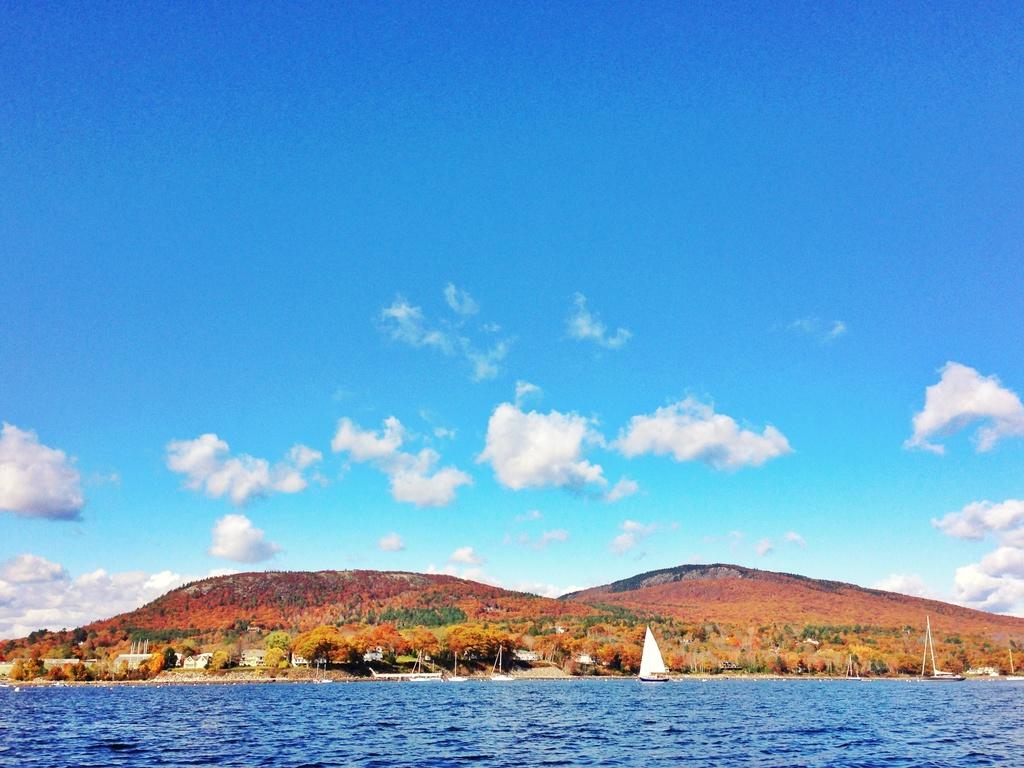What is located at the bottom of the image? There are boats, water, houses, trees, and hills at the bottom of the image. What type of environment is depicted at the bottom of the image? The environment at the bottom of the image includes water, houses, trees, and hills. What is visible in the background of the image? The sky is visible in the background of the image. What can be observed in the sky? The sky has clouds. Can you provide an example of a goose in the image? There is no goose present in the image. What type of cord is used to connect the boats in the image? There is no cord connecting the boats in the image; they are simply located in the water. 